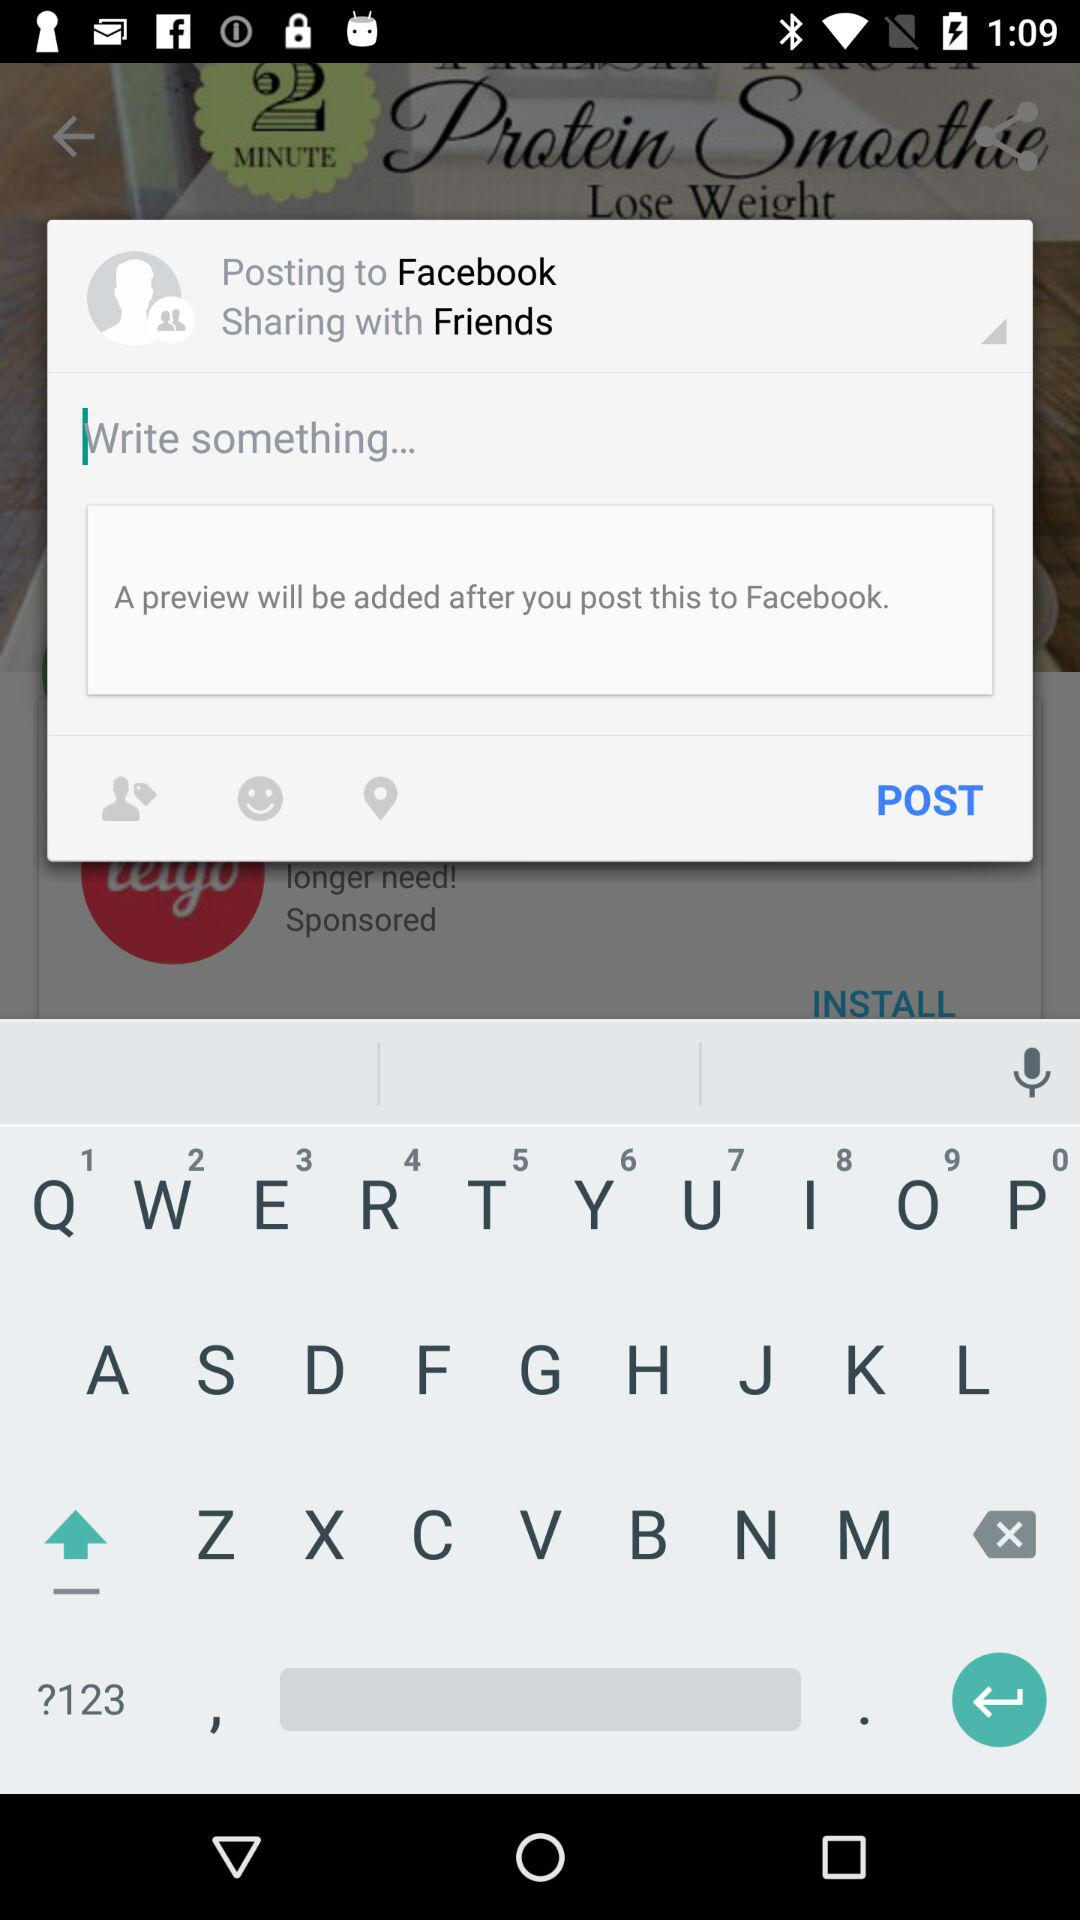How many languages are available for selection?
Answer the question using a single word or phrase. 5 